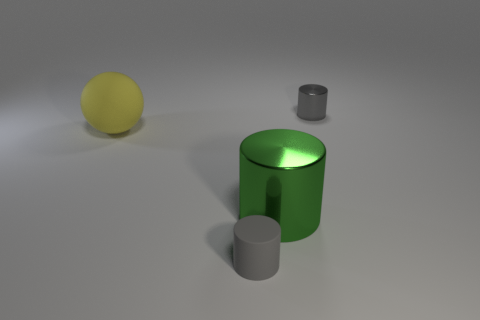Subtract all gray cylinders. How many cylinders are left? 1 Add 1 tiny rubber things. How many objects exist? 5 Subtract 2 cylinders. How many cylinders are left? 1 Subtract all green cylinders. How many cylinders are left? 2 Subtract all balls. How many objects are left? 3 Add 3 yellow spheres. How many yellow spheres exist? 4 Subtract 0 purple blocks. How many objects are left? 4 Subtract all green cylinders. Subtract all yellow balls. How many cylinders are left? 2 Subtract all brown blocks. How many purple balls are left? 0 Subtract all yellow metal blocks. Subtract all big rubber spheres. How many objects are left? 3 